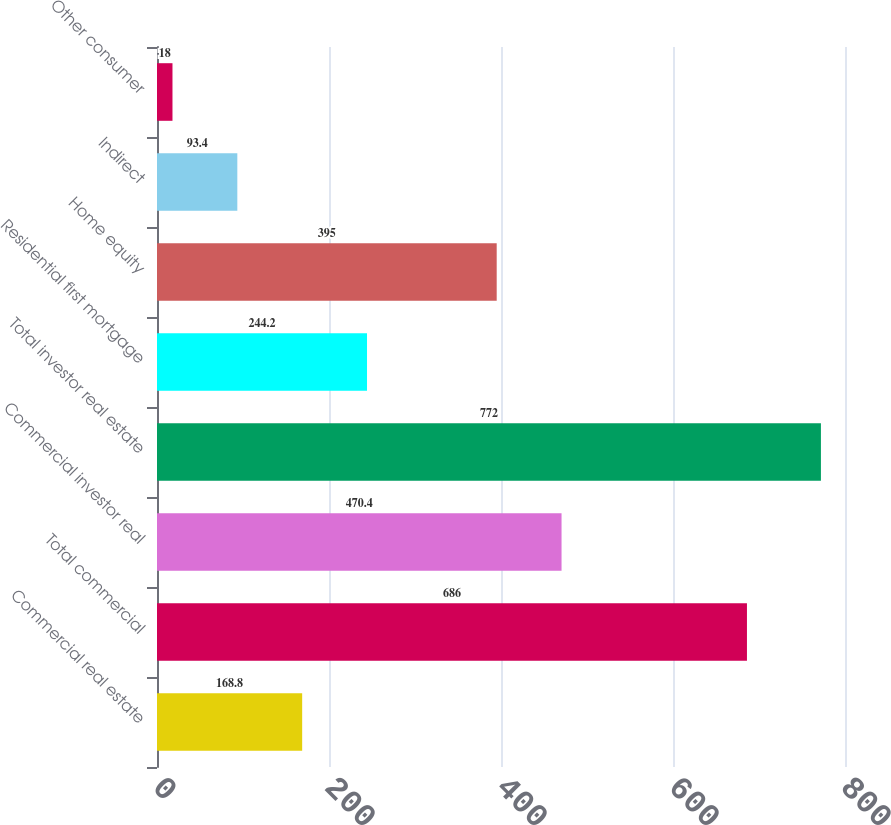Convert chart. <chart><loc_0><loc_0><loc_500><loc_500><bar_chart><fcel>Commercial real estate<fcel>Total commercial<fcel>Commercial investor real<fcel>Total investor real estate<fcel>Residential first mortgage<fcel>Home equity<fcel>Indirect<fcel>Other consumer<nl><fcel>168.8<fcel>686<fcel>470.4<fcel>772<fcel>244.2<fcel>395<fcel>93.4<fcel>18<nl></chart> 